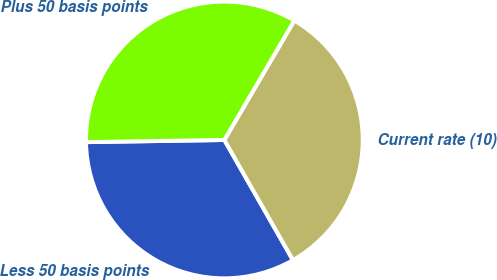Convert chart. <chart><loc_0><loc_0><loc_500><loc_500><pie_chart><fcel>Less 50 basis points<fcel>Current rate (10)<fcel>Plus 50 basis points<nl><fcel>33.01%<fcel>33.31%<fcel>33.68%<nl></chart> 